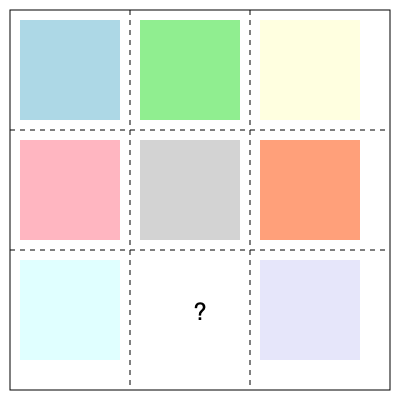In the given 3x3 grid layout for a UI design, seven elements have been placed. Which position should the eighth element occupy to achieve optimal visual balance? To determine the optimal position for the eighth element, we need to consider the principles of visual balance and symmetry in UI design:

1. Analyze the current layout:
   - The grid is 3x3, with 9 possible positions.
   - 7 out of 9 positions are already filled.
   - The empty spaces are in the middle-bottom and bottom-right positions.

2. Consider symmetry:
   - The top row is fully occupied.
   - The left column is fully occupied.
   - The right column is missing one element at the bottom.

3. Evaluate visual weight:
   - The current layout has more weight on the top and left sides.
   - Adding an element to the bottom-right would balance this weight.

4. Apply the rule of odds:
   - Odd numbers of elements are often more visually appealing.
   - Placing the 8th element would create a 3x3 grid with 8 filled spaces, setting up for a complete 9-element layout.

5. Consider user scanning patterns:
   - Users often scan in an F or Z pattern.
   - Placing the element in the bottom-right guides the eye through the entire layout.

6. Future expandability:
   - Leaving the center-bottom space open allows for potential expansion or a centered call-to-action in the future.

Based on these considerations, the optimal position for the eighth element to achieve visual balance is the bottom-right corner of the grid.
Answer: Bottom-right corner 